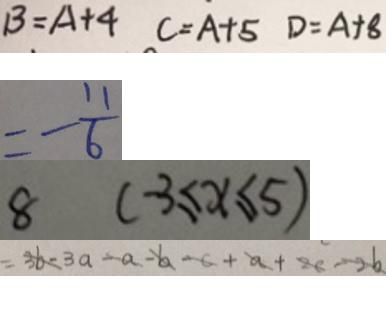<formula> <loc_0><loc_0><loc_500><loc_500>B = A + 4 C = A + 5 D = A + 8 
 = - \frac { 1 1 } { 6 } 
 8 ( - 3 \leq x \leq 5 ) 
 = 3 b - 3 a - a - b - c + a + 2 c - 2 b</formula> 